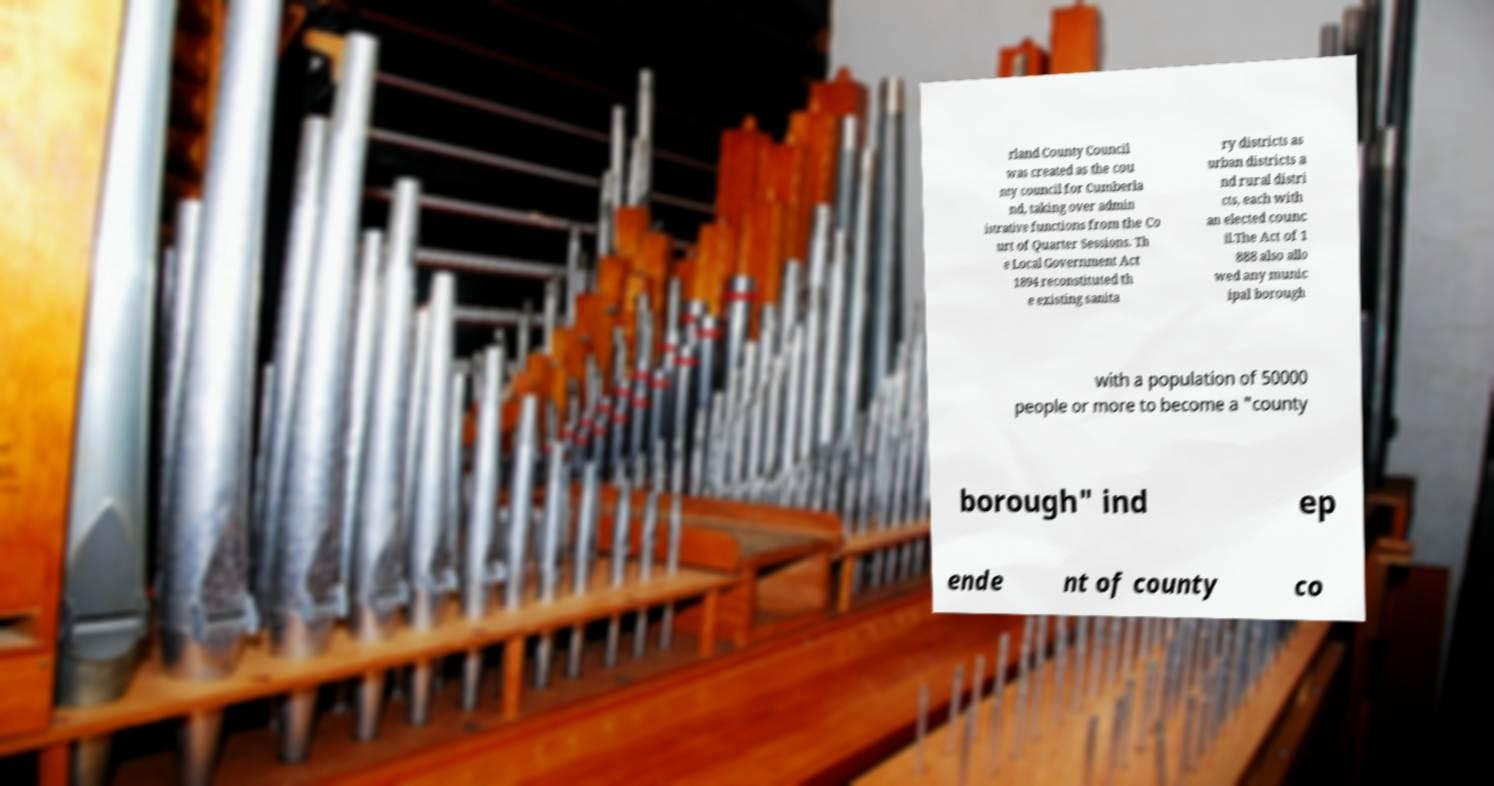Could you extract and type out the text from this image? rland County Council was created as the cou nty council for Cumberla nd, taking over admin istrative functions from the Co urt of Quarter Sessions. Th e Local Government Act 1894 reconstituted th e existing sanita ry districts as urban districts a nd rural distri cts, each with an elected counc il.The Act of 1 888 also allo wed any munic ipal borough with a population of 50000 people or more to become a "county borough" ind ep ende nt of county co 